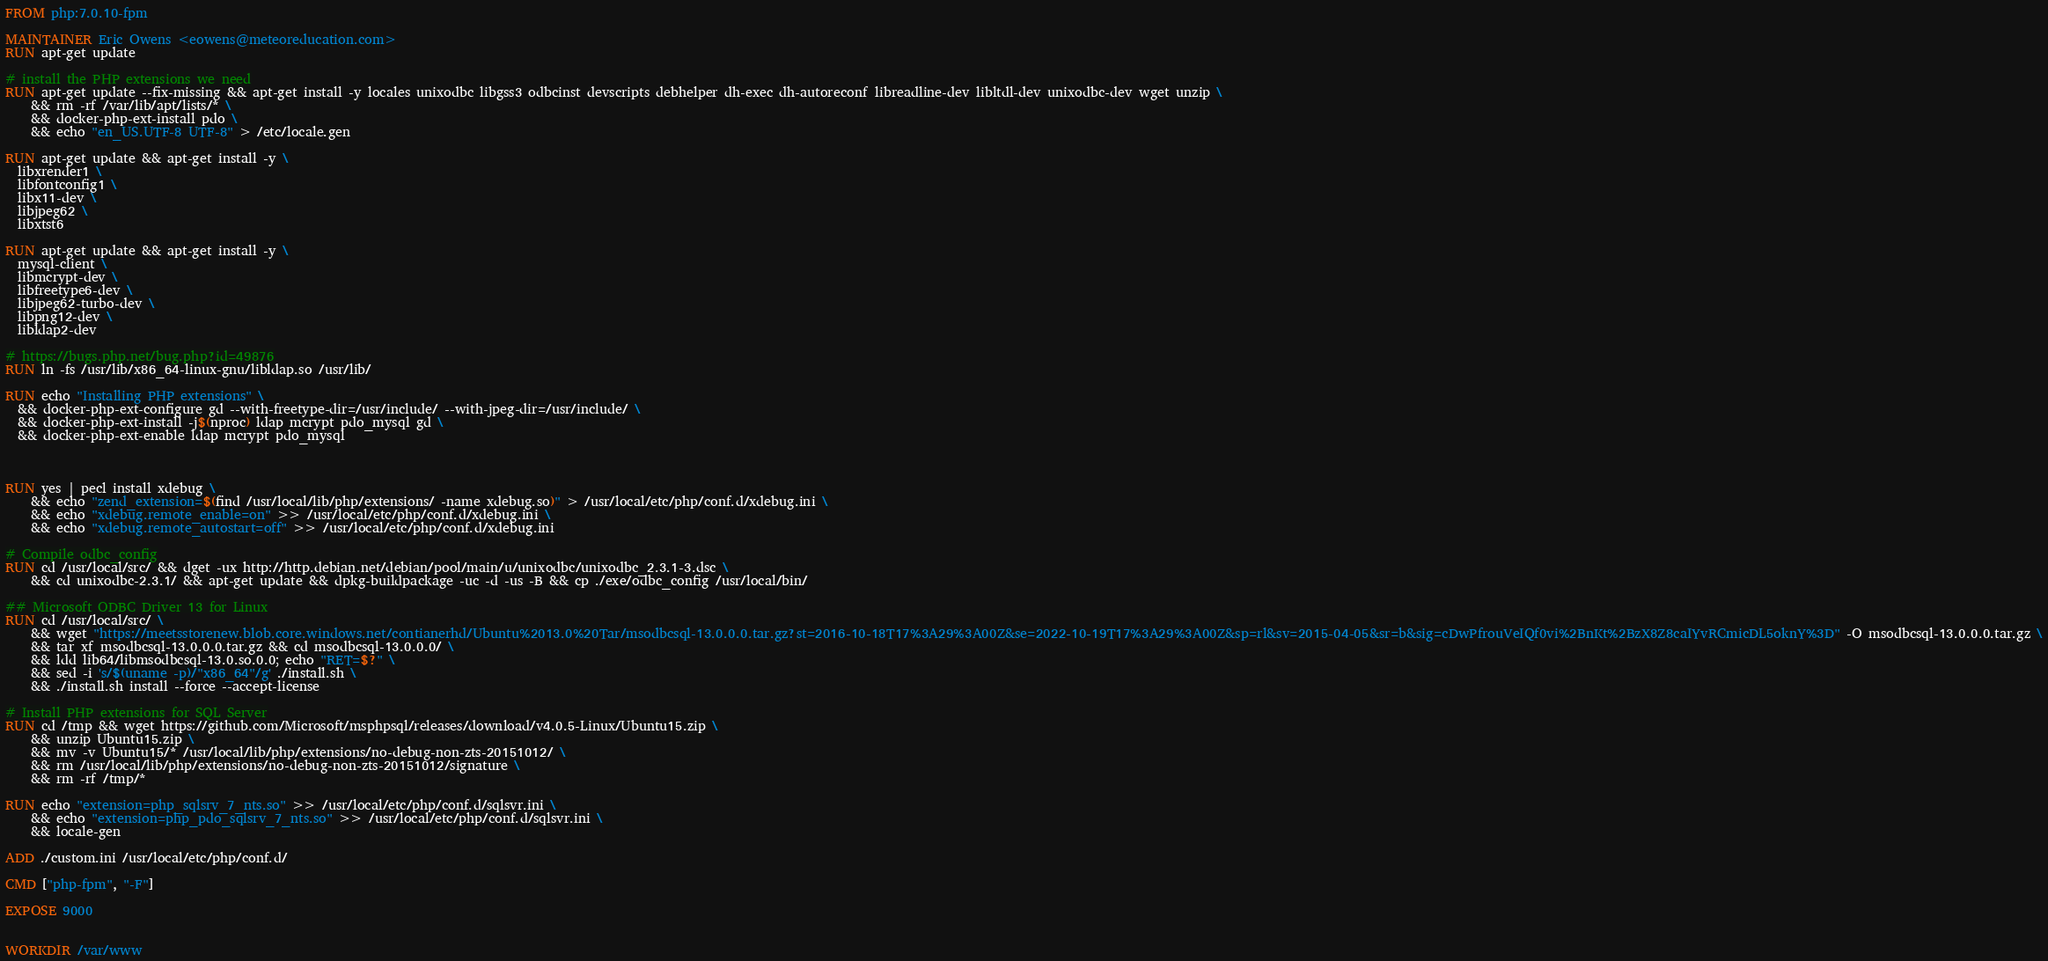<code> <loc_0><loc_0><loc_500><loc_500><_Dockerfile_>FROM php:7.0.10-fpm

MAINTAINER Eric Owens <eowens@meteoreducation.com>
RUN apt-get update

# install the PHP extensions we need
RUN apt-get update --fix-missing && apt-get install -y locales unixodbc libgss3 odbcinst devscripts debhelper dh-exec dh-autoreconf libreadline-dev libltdl-dev unixodbc-dev wget unzip \
    && rm -rf /var/lib/apt/lists/* \
    && docker-php-ext-install pdo \
    && echo "en_US.UTF-8 UTF-8" > /etc/locale.gen

RUN apt-get update && apt-get install -y \
  libxrender1 \
  libfontconfig1 \
  libx11-dev \
  libjpeg62 \
  libxtst6

RUN apt-get update && apt-get install -y \
  mysql-client \
  libmcrypt-dev \
  libfreetype6-dev \
  libjpeg62-turbo-dev \
  libpng12-dev \
  libldap2-dev

# https://bugs.php.net/bug.php?id=49876
RUN ln -fs /usr/lib/x86_64-linux-gnu/libldap.so /usr/lib/

RUN echo "Installing PHP extensions" \
  && docker-php-ext-configure gd --with-freetype-dir=/usr/include/ --with-jpeg-dir=/usr/include/ \
  && docker-php-ext-install -j$(nproc) ldap mcrypt pdo_mysql gd \
  && docker-php-ext-enable ldap mcrypt pdo_mysql



RUN yes | pecl install xdebug \
    && echo "zend_extension=$(find /usr/local/lib/php/extensions/ -name xdebug.so)" > /usr/local/etc/php/conf.d/xdebug.ini \
    && echo "xdebug.remote_enable=on" >> /usr/local/etc/php/conf.d/xdebug.ini \
    && echo "xdebug.remote_autostart=off" >> /usr/local/etc/php/conf.d/xdebug.ini

# Compile odbc_config
RUN cd /usr/local/src/ && dget -ux http://http.debian.net/debian/pool/main/u/unixodbc/unixodbc_2.3.1-3.dsc \
    && cd unixodbc-2.3.1/ && apt-get update && dpkg-buildpackage -uc -d -us -B && cp ./exe/odbc_config /usr/local/bin/

## Microsoft ODBC Driver 13 for Linux
RUN cd /usr/local/src/ \
    && wget "https://meetsstorenew.blob.core.windows.net/contianerhd/Ubuntu%2013.0%20Tar/msodbcsql-13.0.0.0.tar.gz?st=2016-10-18T17%3A29%3A00Z&se=2022-10-19T17%3A29%3A00Z&sp=rl&sv=2015-04-05&sr=b&sig=cDwPfrouVeIQf0vi%2BnKt%2BzX8Z8caIYvRCmicDL5oknY%3D" -O msodbcsql-13.0.0.0.tar.gz \
    && tar xf msodbcsql-13.0.0.0.tar.gz && cd msodbcsql-13.0.0.0/ \
    && ldd lib64/libmsodbcsql-13.0.so.0.0; echo "RET=$?" \
    && sed -i 's/$(uname -p)/"x86_64"/g' ./install.sh \
    && ./install.sh install --force --accept-license

# Install PHP extensions for SQL Server
RUN cd /tmp && wget https://github.com/Microsoft/msphpsql/releases/download/v4.0.5-Linux/Ubuntu15.zip \
    && unzip Ubuntu15.zip \
    && mv -v Ubuntu15/* /usr/local/lib/php/extensions/no-debug-non-zts-20151012/ \
    && rm /usr/local/lib/php/extensions/no-debug-non-zts-20151012/signature \
    && rm -rf /tmp/*

RUN echo "extension=php_sqlsrv_7_nts.so" >> /usr/local/etc/php/conf.d/sqlsvr.ini \
    && echo "extension=php_pdo_sqlsrv_7_nts.so" >> /usr/local/etc/php/conf.d/sqlsvr.ini \
    && locale-gen

ADD ./custom.ini /usr/local/etc/php/conf.d/

CMD ["php-fpm", "-F"]

EXPOSE 9000


WORKDIR /var/www
</code> 